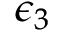<formula> <loc_0><loc_0><loc_500><loc_500>\epsilon _ { 3 }</formula> 